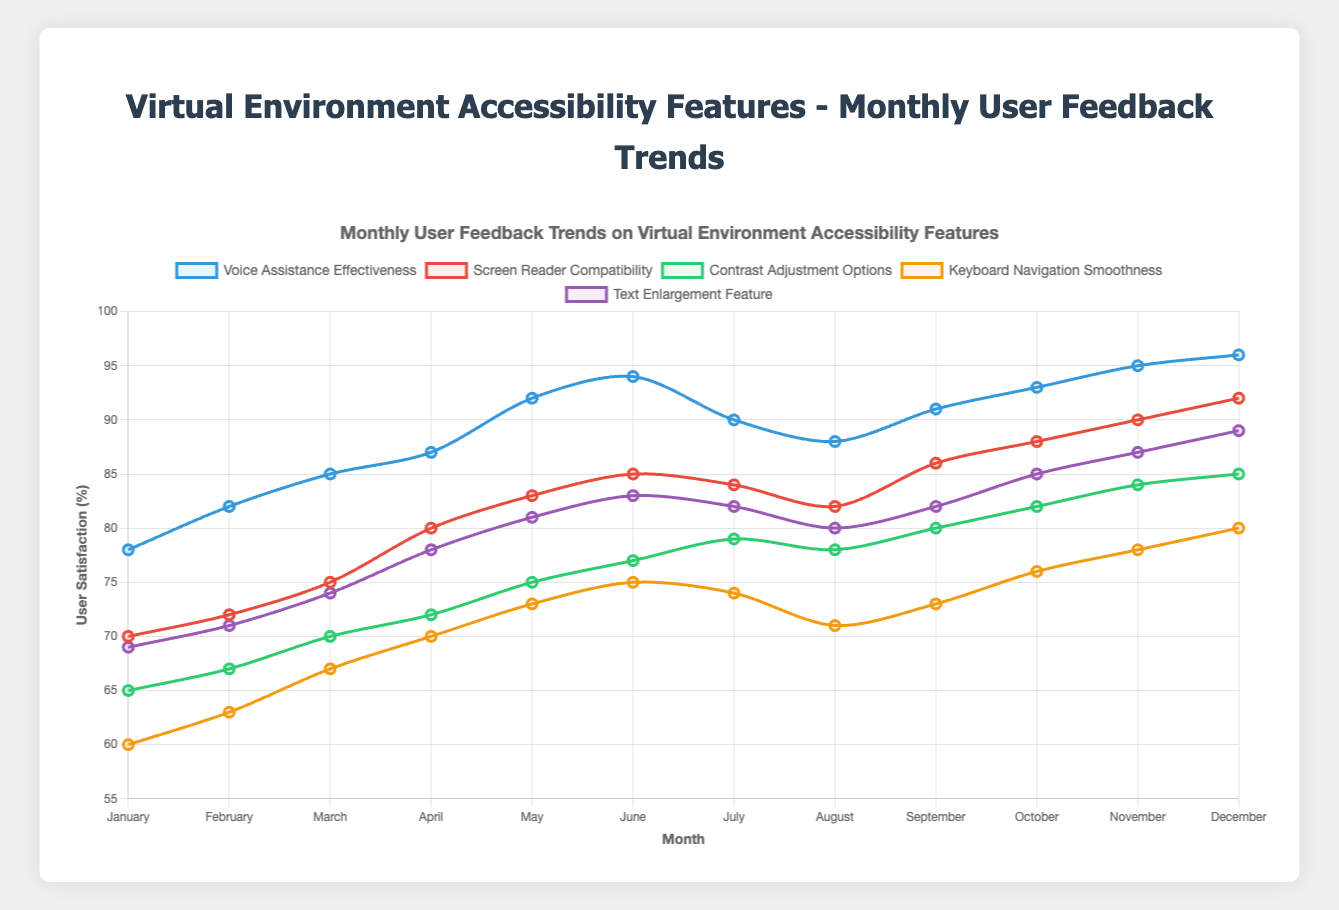What is the trend of user satisfaction for Voice Assistance Effectiveness from January to December? The user satisfaction for Voice Assistance Effectiveness starts at 78 in January and generally increases over the months, reaching 96 in December.
Answer: Increasing Which month shows the highest user satisfaction for Screen Reader Compatibility? By looking at the data points for Screen Reader Compatibility across all months, the highest value is 92 in December.
Answer: December How does the satisfaction for Text Enlargement Feature in August compare to March? In March, the satisfaction is 74, and in August, it is 80.
Answer: Higher in August What is the average satisfaction of Keyboard Navigation Smoothness for the first half of the year? The Keyboard Navigation Smoothness satisfaction values for the first six months are 60, 63, 67, 70, 73, and 75. Adding these values and dividing by 6 gives (60+63+67+70+73+75)/6 = 68.
Answer: 68 Across all features, which one has the lowest satisfaction score in January? Comparing the January values: Voice Assistance Effectiveness 78, Screen Reader Compatibility 70, Contrast Adjustment Options 65, Keyboard Navigation Smoothness 60, and Text Enlargement Feature 69. The lowest is Keyboard Navigation Smoothness at 60.
Answer: Keyboard Navigation Smoothness What is the difference in satisfaction for Contrast Adjustment Options between May and July? The satisfaction for Contrast Adjustment Options is 75 in May and 79 in July. The difference is 79 - 75 = 4.
Answer: 4 Which feature shows the most dramatic increase in user satisfaction over the year? By calculating the difference between December and January values for each feature: 
- Voice Assistance Effectiveness: 96 - 78 = 18
- Screen Reader Compatibility: 92 - 70 = 22
- Contrast Adjustment Options: 85 - 65 = 20
- Keyboard Navigation Smoothness: 80 - 60 = 20
- Text Enlargement Feature: 89 - 69 = 20
The most dramatic increase is for Screen Reader Compatibility with 22.
Answer: Screen Reader Compatibility How does the satisfaction trend of Screen Reader Compatibility compare to Text Enlargement Feature throughout the year? Both have an increasing trend, but Screen Reader Compatibility starts lower at 70 in January and reaches 92 in December, while Text Enlargement starts at 69 and ends at 89. The trends are fairly similar, but Screen Reader Compatibility has a slightly steeper increase.
Answer: Similar, with Screen Reader Compatibility having a steeper increase Which two months show the highest satisfaction for Contrast Adjustment Options? The highest satisfaction values for Contrast Adjustment Options are in November (84) and December (85).
Answer: November and December 